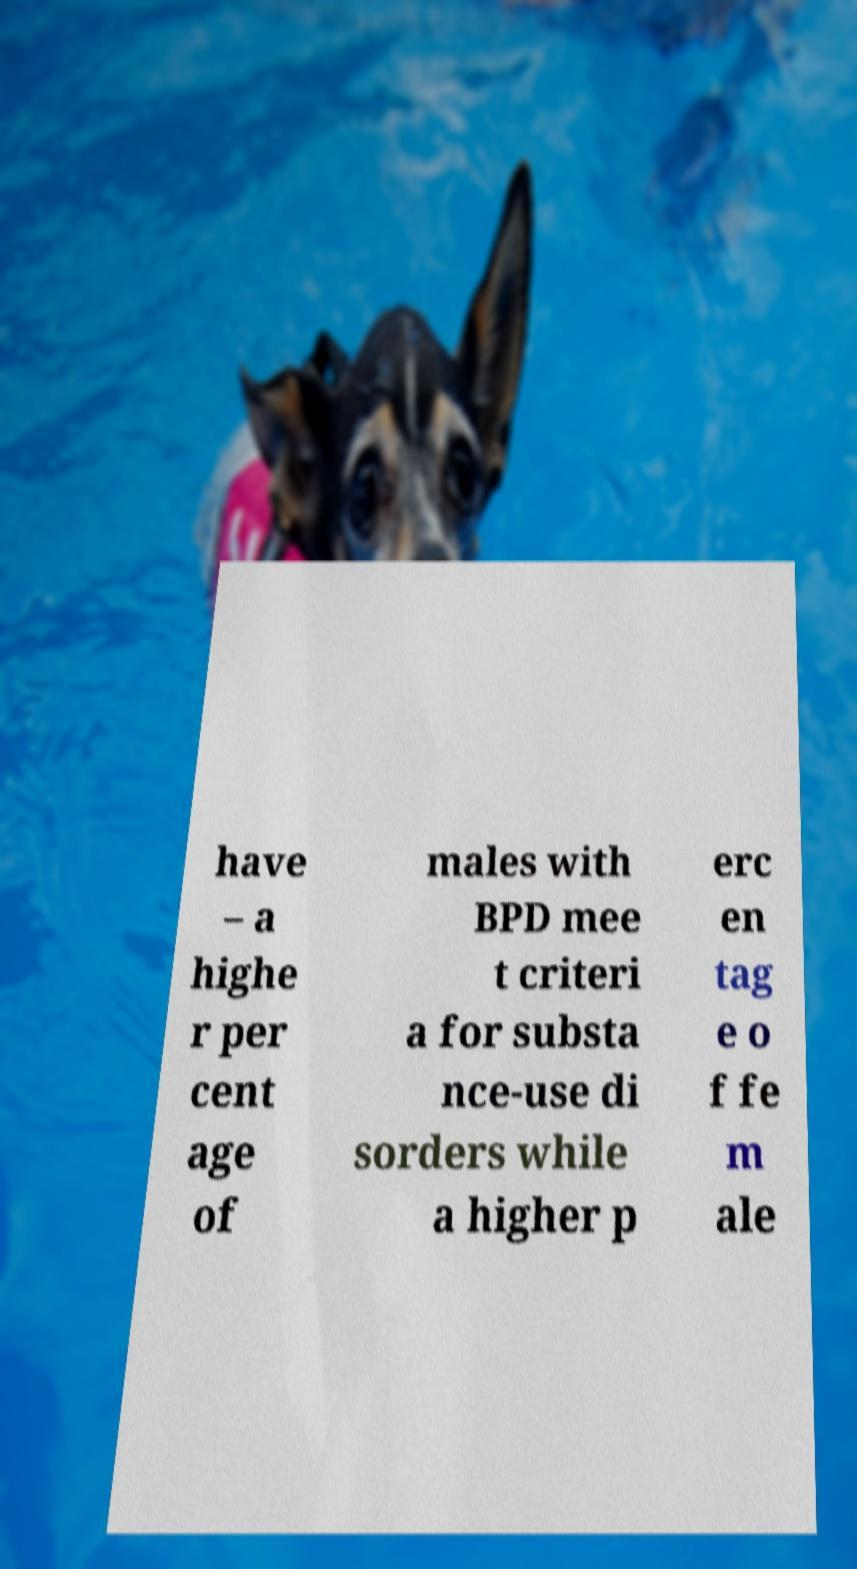Could you assist in decoding the text presented in this image and type it out clearly? have – a highe r per cent age of males with BPD mee t criteri a for substa nce-use di sorders while a higher p erc en tag e o f fe m ale 